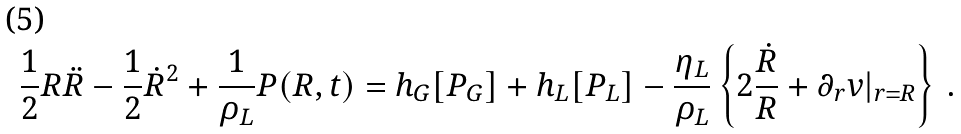Convert formula to latex. <formula><loc_0><loc_0><loc_500><loc_500>\frac { 1 } { 2 } R \ddot { R } - \frac { 1 } { 2 } \dot { R } ^ { 2 } + \frac { 1 } { \rho _ { L } } P ( R , t ) = h _ { G } [ P _ { G } ] + h _ { L } [ P _ { L } ] - \frac { \eta _ { L } } { \rho _ { L } } \left \{ 2 \frac { \dot { R } } { R } + \partial _ { r } v | _ { r = R } \right \} \, .</formula> 